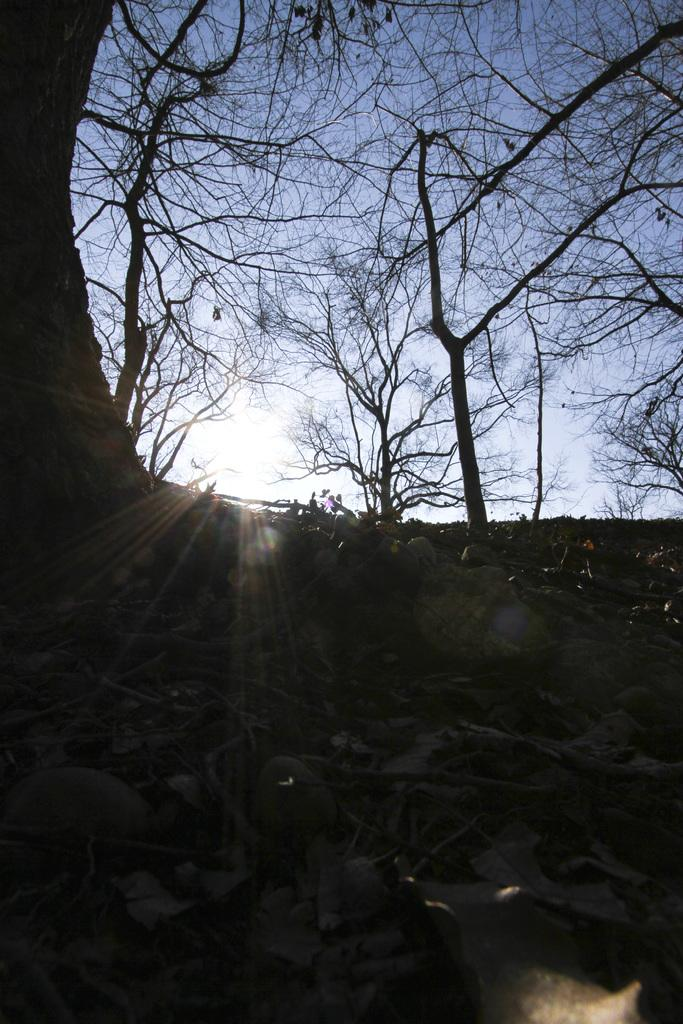What type of vegetation can be seen in the image? There are trees in the image. What is visible beneath the trees? There is ground visible in the image. What can be found on the ground in the image? Leaves are present on the ground. What is visible in the background of the image? The sky is visible in the background of the image. What type of metal base can be seen supporting the wall in the image? There is no metal base or wall present in the image; it features trees, ground, leaves, and the sky. 